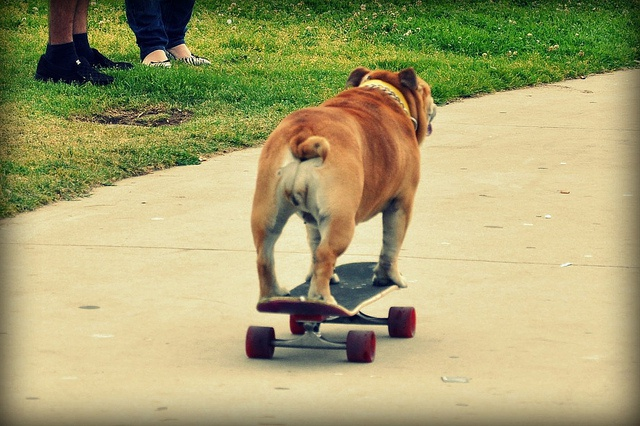Describe the objects in this image and their specific colors. I can see dog in darkgreen, tan, brown, and gray tones, skateboard in darkgreen, black, gray, blue, and purple tones, people in darkgreen, black, maroon, olive, and gray tones, and people in darkgreen, black, navy, tan, and olive tones in this image. 